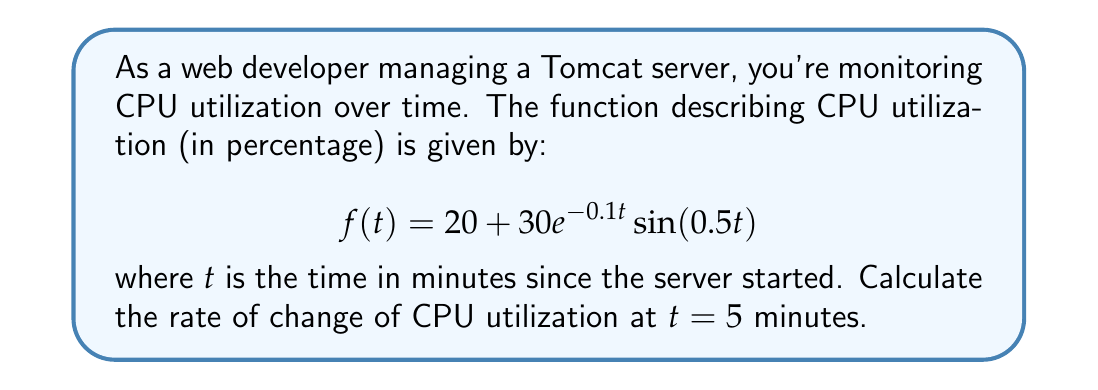What is the answer to this math problem? To find the rate of change of CPU utilization at $t = 5$ minutes, we need to calculate the derivative of $f(t)$ and then evaluate it at $t = 5$.

1) Let's start by applying the product rule to differentiate $f(t)$:
   $$f'(t) = \frac{d}{dt}[20 + 30e^{-0.1t} \sin(0.5t)]$$
   $$f'(t) = 0 + 30\frac{d}{dt}[e^{-0.1t} \sin(0.5t)]$$

2) Using the product rule:
   $$f'(t) = 30[e^{-0.1t} \cdot \frac{d}{dt}\sin(0.5t) + \sin(0.5t) \cdot \frac{d}{dt}e^{-0.1t}]$$

3) Evaluate the derivatives:
   $$f'(t) = 30[e^{-0.1t} \cdot 0.5\cos(0.5t) + \sin(0.5t) \cdot (-0.1e^{-0.1t})]$$

4) Simplify:
   $$f'(t) = 30e^{-0.1t}[0.5\cos(0.5t) - 0.1\sin(0.5t)]$$

5) Now, evaluate at $t = 5$:
   $$f'(5) = 30e^{-0.5}[0.5\cos(2.5) - 0.1\sin(2.5)]$$

6) Calculate the numerical value:
   $$f'(5) \approx 30 \cdot 0.6065 \cdot [0.5 \cdot (-0.8011) - 0.1 \cdot 0.5985]$$
   $$f'(5) \approx -7.3$$

The negative value indicates that the CPU utilization is decreasing at $t = 5$ minutes.
Answer: $f'(5) \approx -7.3$ percentage points per minute 